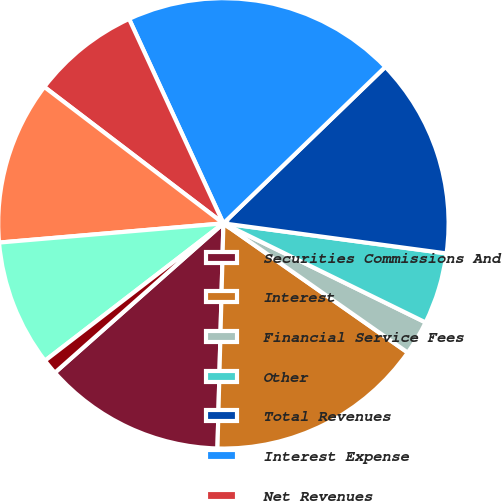Convert chart to OTSL. <chart><loc_0><loc_0><loc_500><loc_500><pie_chart><fcel>Securities Commissions And<fcel>Interest<fcel>Financial Service Fees<fcel>Other<fcel>Total Revenues<fcel>Interest Expense<fcel>Net Revenues<fcel>Sales Commissions<fcel>Admin & Incentive Comp and<fcel>Communications and Information<nl><fcel>13.04%<fcel>15.69%<fcel>2.48%<fcel>5.12%<fcel>14.36%<fcel>19.65%<fcel>7.76%<fcel>11.72%<fcel>9.08%<fcel>1.1%<nl></chart> 